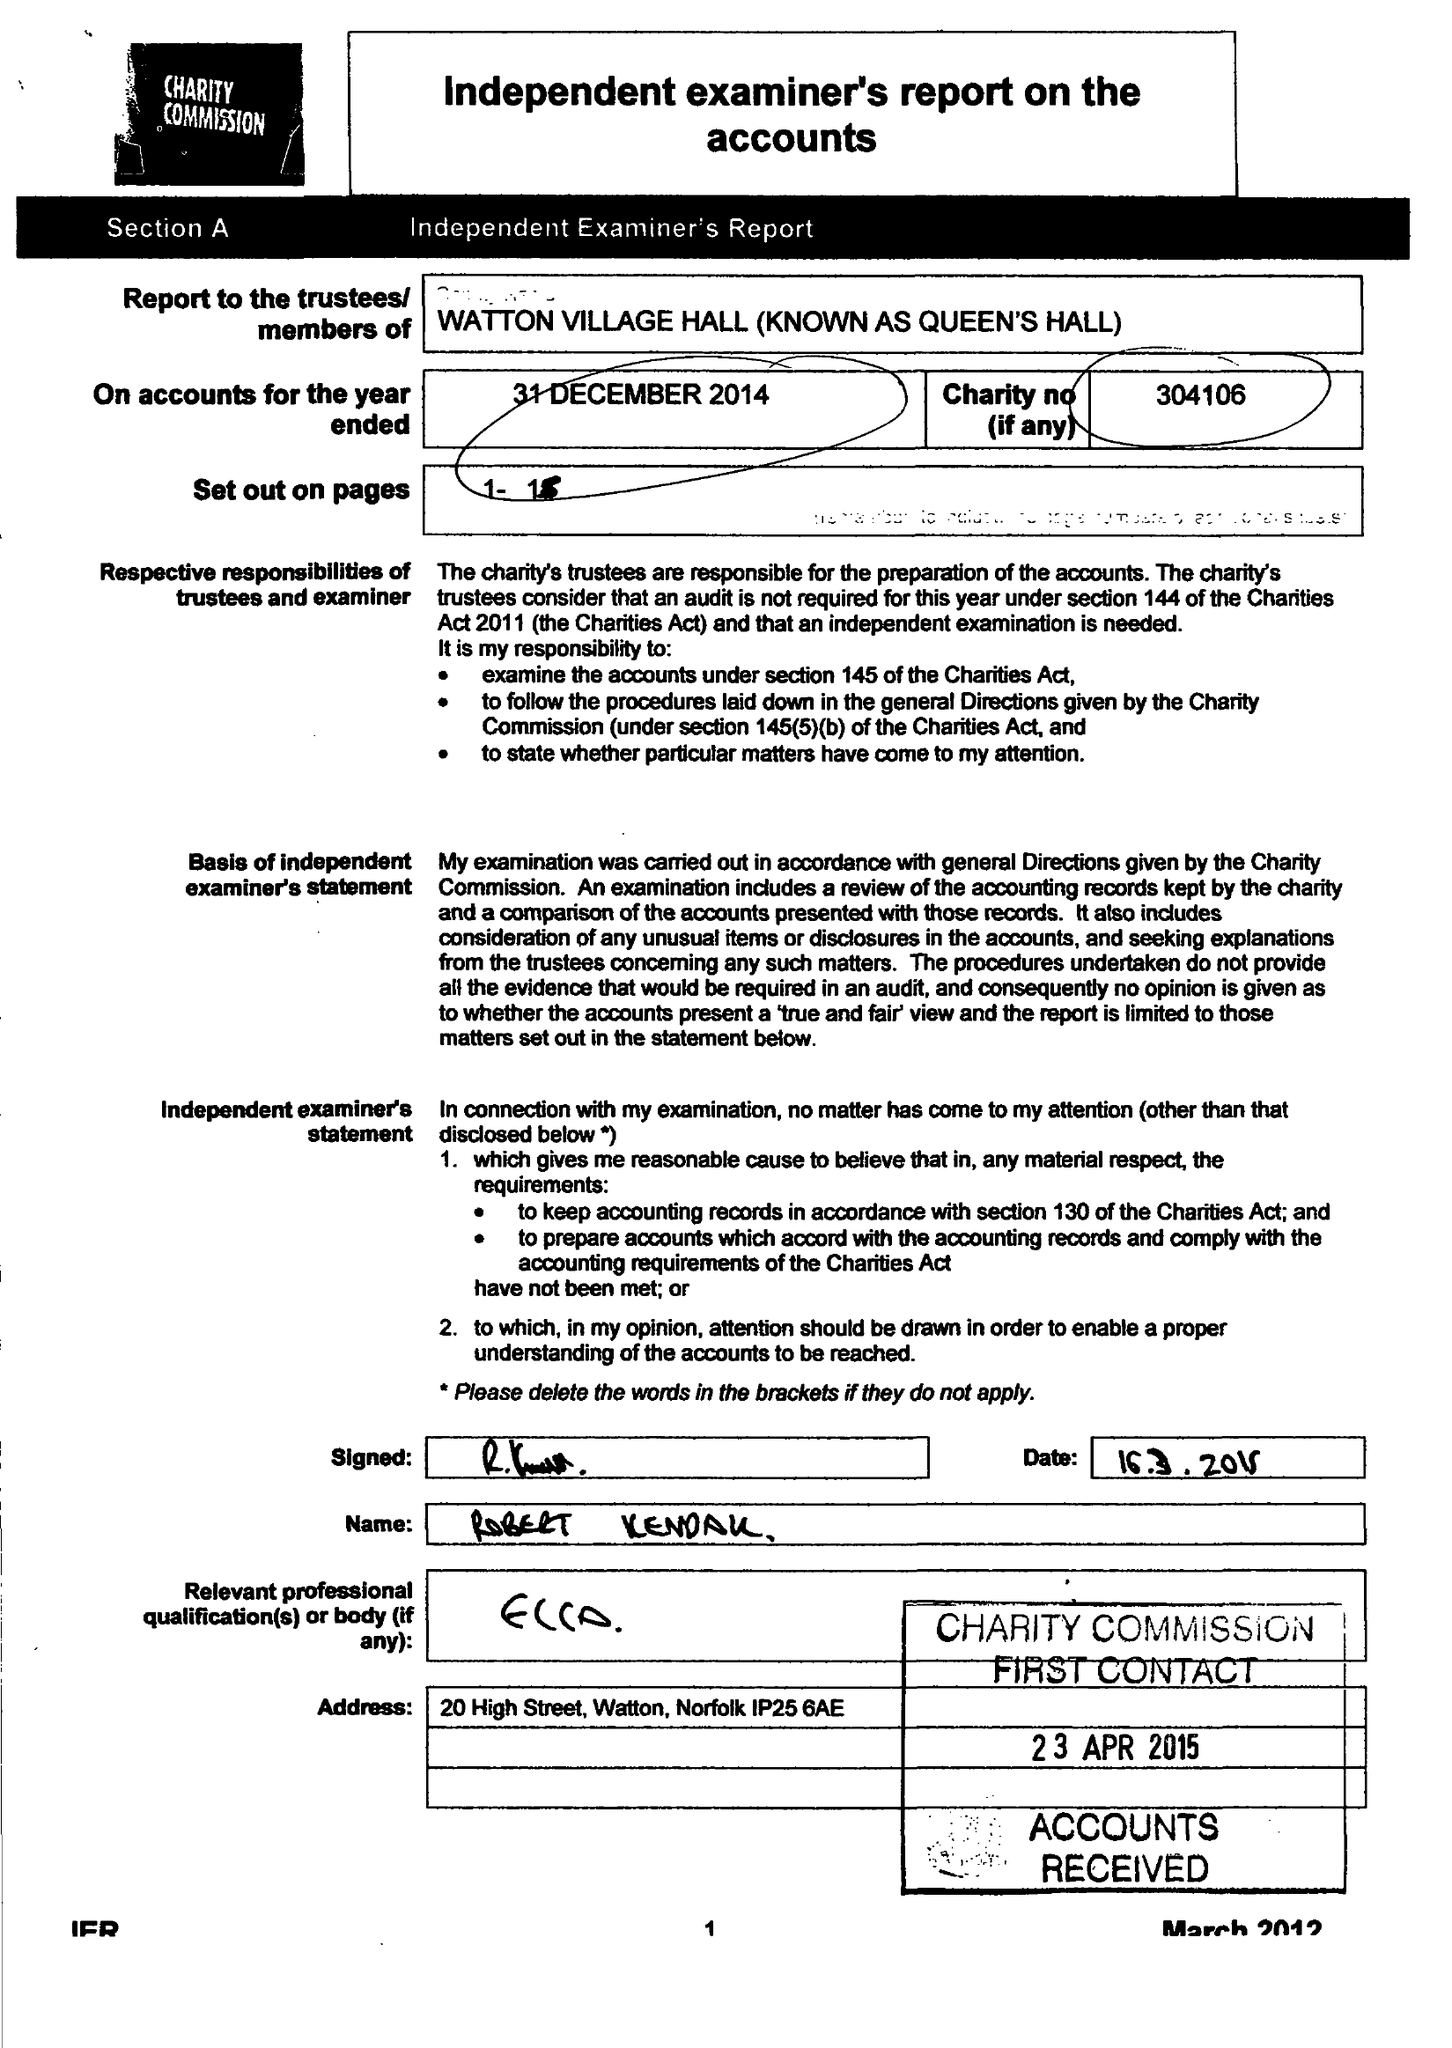What is the value for the charity_name?
Answer the question using a single word or phrase. Watton Village Hall (Known As Queen's Hall) 